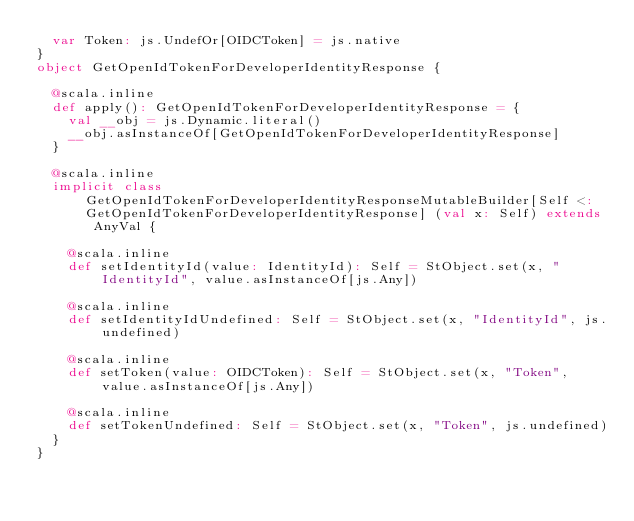Convert code to text. <code><loc_0><loc_0><loc_500><loc_500><_Scala_>  var Token: js.UndefOr[OIDCToken] = js.native
}
object GetOpenIdTokenForDeveloperIdentityResponse {
  
  @scala.inline
  def apply(): GetOpenIdTokenForDeveloperIdentityResponse = {
    val __obj = js.Dynamic.literal()
    __obj.asInstanceOf[GetOpenIdTokenForDeveloperIdentityResponse]
  }
  
  @scala.inline
  implicit class GetOpenIdTokenForDeveloperIdentityResponseMutableBuilder[Self <: GetOpenIdTokenForDeveloperIdentityResponse] (val x: Self) extends AnyVal {
    
    @scala.inline
    def setIdentityId(value: IdentityId): Self = StObject.set(x, "IdentityId", value.asInstanceOf[js.Any])
    
    @scala.inline
    def setIdentityIdUndefined: Self = StObject.set(x, "IdentityId", js.undefined)
    
    @scala.inline
    def setToken(value: OIDCToken): Self = StObject.set(x, "Token", value.asInstanceOf[js.Any])
    
    @scala.inline
    def setTokenUndefined: Self = StObject.set(x, "Token", js.undefined)
  }
}
</code> 